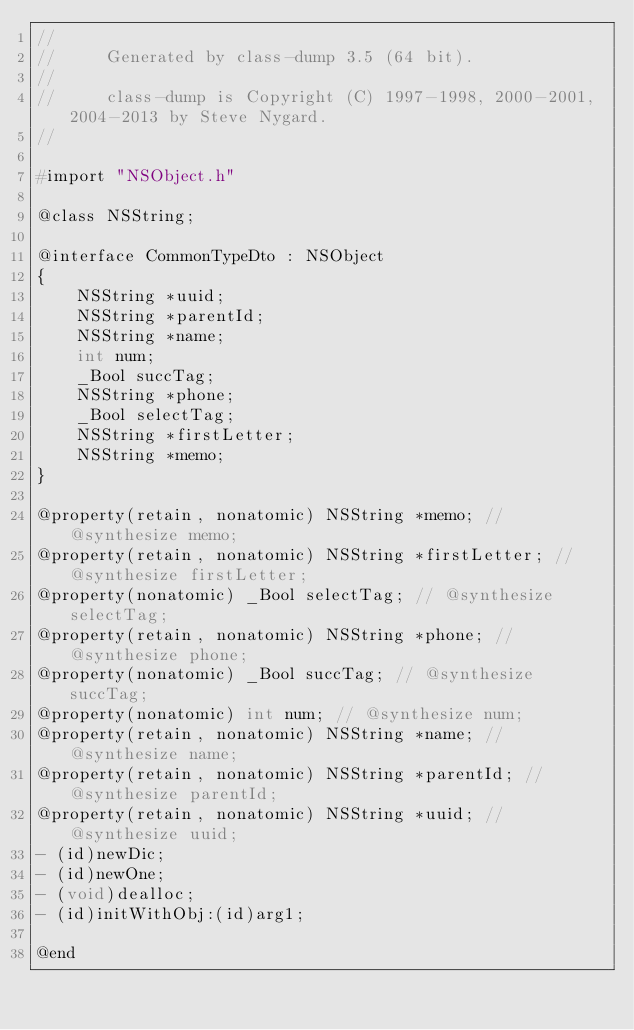Convert code to text. <code><loc_0><loc_0><loc_500><loc_500><_C_>//
//     Generated by class-dump 3.5 (64 bit).
//
//     class-dump is Copyright (C) 1997-1998, 2000-2001, 2004-2013 by Steve Nygard.
//

#import "NSObject.h"

@class NSString;

@interface CommonTypeDto : NSObject
{
    NSString *uuid;
    NSString *parentId;
    NSString *name;
    int num;
    _Bool succTag;
    NSString *phone;
    _Bool selectTag;
    NSString *firstLetter;
    NSString *memo;
}

@property(retain, nonatomic) NSString *memo; // @synthesize memo;
@property(retain, nonatomic) NSString *firstLetter; // @synthesize firstLetter;
@property(nonatomic) _Bool selectTag; // @synthesize selectTag;
@property(retain, nonatomic) NSString *phone; // @synthesize phone;
@property(nonatomic) _Bool succTag; // @synthesize succTag;
@property(nonatomic) int num; // @synthesize num;
@property(retain, nonatomic) NSString *name; // @synthesize name;
@property(retain, nonatomic) NSString *parentId; // @synthesize parentId;
@property(retain, nonatomic) NSString *uuid; // @synthesize uuid;
- (id)newDic;
- (id)newOne;
- (void)dealloc;
- (id)initWithObj:(id)arg1;

@end

</code> 